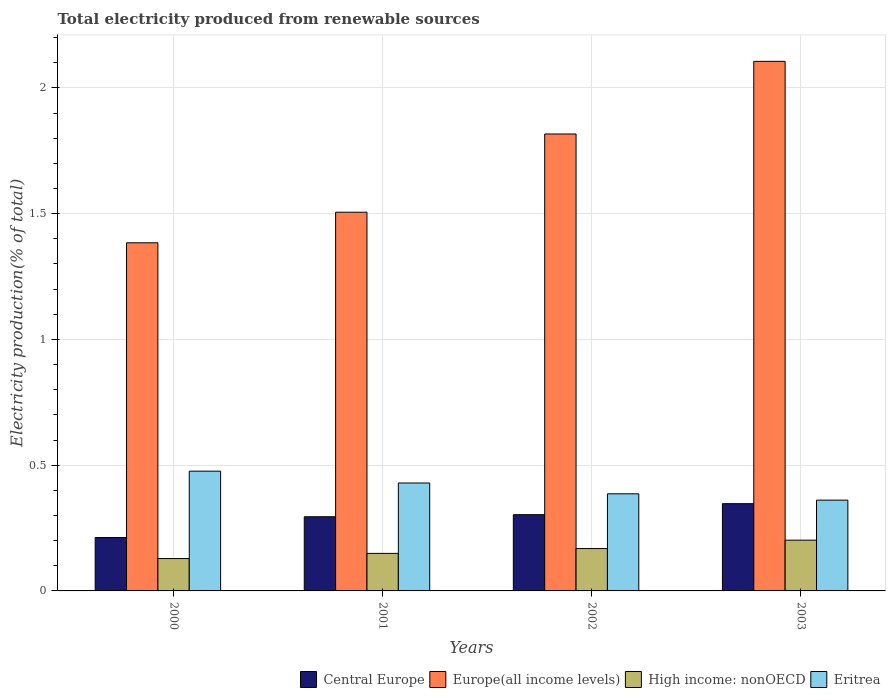How many different coloured bars are there?
Provide a succinct answer. 4. How many groups of bars are there?
Provide a succinct answer. 4. Are the number of bars per tick equal to the number of legend labels?
Give a very brief answer. Yes. Are the number of bars on each tick of the X-axis equal?
Ensure brevity in your answer.  Yes. How many bars are there on the 4th tick from the left?
Your answer should be compact. 4. How many bars are there on the 1st tick from the right?
Keep it short and to the point. 4. What is the label of the 2nd group of bars from the left?
Your answer should be compact. 2001. In how many cases, is the number of bars for a given year not equal to the number of legend labels?
Provide a short and direct response. 0. What is the total electricity produced in Europe(all income levels) in 2000?
Your answer should be compact. 1.38. Across all years, what is the maximum total electricity produced in Europe(all income levels)?
Your response must be concise. 2.11. Across all years, what is the minimum total electricity produced in Eritrea?
Offer a terse response. 0.36. In which year was the total electricity produced in Europe(all income levels) maximum?
Give a very brief answer. 2003. What is the total total electricity produced in Central Europe in the graph?
Keep it short and to the point. 1.16. What is the difference between the total electricity produced in Europe(all income levels) in 2001 and that in 2003?
Offer a very short reply. -0.6. What is the difference between the total electricity produced in Central Europe in 2000 and the total electricity produced in High income: nonOECD in 2001?
Provide a short and direct response. 0.06. What is the average total electricity produced in Central Europe per year?
Offer a terse response. 0.29. In the year 2003, what is the difference between the total electricity produced in Central Europe and total electricity produced in High income: nonOECD?
Make the answer very short. 0.15. In how many years, is the total electricity produced in Eritrea greater than 1.2 %?
Offer a terse response. 0. What is the ratio of the total electricity produced in High income: nonOECD in 2001 to that in 2002?
Your answer should be very brief. 0.89. Is the total electricity produced in High income: nonOECD in 2000 less than that in 2001?
Your response must be concise. Yes. Is the difference between the total electricity produced in Central Europe in 2000 and 2002 greater than the difference between the total electricity produced in High income: nonOECD in 2000 and 2002?
Keep it short and to the point. No. What is the difference between the highest and the second highest total electricity produced in Europe(all income levels)?
Offer a terse response. 0.29. What is the difference between the highest and the lowest total electricity produced in Eritrea?
Your response must be concise. 0.12. In how many years, is the total electricity produced in Europe(all income levels) greater than the average total electricity produced in Europe(all income levels) taken over all years?
Provide a short and direct response. 2. What does the 3rd bar from the left in 2001 represents?
Keep it short and to the point. High income: nonOECD. What does the 1st bar from the right in 2002 represents?
Your answer should be very brief. Eritrea. Are all the bars in the graph horizontal?
Your response must be concise. No. How many years are there in the graph?
Offer a terse response. 4. What is the difference between two consecutive major ticks on the Y-axis?
Make the answer very short. 0.5. Does the graph contain grids?
Keep it short and to the point. Yes. Where does the legend appear in the graph?
Your response must be concise. Bottom right. How are the legend labels stacked?
Provide a short and direct response. Horizontal. What is the title of the graph?
Ensure brevity in your answer.  Total electricity produced from renewable sources. Does "Mauritania" appear as one of the legend labels in the graph?
Provide a succinct answer. No. What is the label or title of the X-axis?
Give a very brief answer. Years. What is the label or title of the Y-axis?
Your response must be concise. Electricity production(% of total). What is the Electricity production(% of total) in Central Europe in 2000?
Keep it short and to the point. 0.21. What is the Electricity production(% of total) of Europe(all income levels) in 2000?
Offer a terse response. 1.38. What is the Electricity production(% of total) in High income: nonOECD in 2000?
Offer a terse response. 0.13. What is the Electricity production(% of total) in Eritrea in 2000?
Offer a very short reply. 0.48. What is the Electricity production(% of total) in Central Europe in 2001?
Provide a succinct answer. 0.29. What is the Electricity production(% of total) in Europe(all income levels) in 2001?
Your response must be concise. 1.51. What is the Electricity production(% of total) of High income: nonOECD in 2001?
Give a very brief answer. 0.15. What is the Electricity production(% of total) in Eritrea in 2001?
Keep it short and to the point. 0.43. What is the Electricity production(% of total) in Central Europe in 2002?
Your answer should be compact. 0.3. What is the Electricity production(% of total) of Europe(all income levels) in 2002?
Your answer should be compact. 1.82. What is the Electricity production(% of total) in High income: nonOECD in 2002?
Offer a terse response. 0.17. What is the Electricity production(% of total) of Eritrea in 2002?
Offer a very short reply. 0.39. What is the Electricity production(% of total) in Central Europe in 2003?
Your answer should be compact. 0.35. What is the Electricity production(% of total) of Europe(all income levels) in 2003?
Your answer should be compact. 2.11. What is the Electricity production(% of total) in High income: nonOECD in 2003?
Keep it short and to the point. 0.2. What is the Electricity production(% of total) in Eritrea in 2003?
Your answer should be very brief. 0.36. Across all years, what is the maximum Electricity production(% of total) in Central Europe?
Your answer should be compact. 0.35. Across all years, what is the maximum Electricity production(% of total) in Europe(all income levels)?
Give a very brief answer. 2.11. Across all years, what is the maximum Electricity production(% of total) in High income: nonOECD?
Offer a terse response. 0.2. Across all years, what is the maximum Electricity production(% of total) of Eritrea?
Provide a short and direct response. 0.48. Across all years, what is the minimum Electricity production(% of total) of Central Europe?
Your response must be concise. 0.21. Across all years, what is the minimum Electricity production(% of total) in Europe(all income levels)?
Ensure brevity in your answer.  1.38. Across all years, what is the minimum Electricity production(% of total) of High income: nonOECD?
Provide a succinct answer. 0.13. Across all years, what is the minimum Electricity production(% of total) in Eritrea?
Make the answer very short. 0.36. What is the total Electricity production(% of total) in Central Europe in the graph?
Provide a short and direct response. 1.16. What is the total Electricity production(% of total) in Europe(all income levels) in the graph?
Keep it short and to the point. 6.81. What is the total Electricity production(% of total) of High income: nonOECD in the graph?
Your response must be concise. 0.65. What is the total Electricity production(% of total) of Eritrea in the graph?
Your answer should be very brief. 1.65. What is the difference between the Electricity production(% of total) of Central Europe in 2000 and that in 2001?
Provide a succinct answer. -0.08. What is the difference between the Electricity production(% of total) in Europe(all income levels) in 2000 and that in 2001?
Offer a terse response. -0.12. What is the difference between the Electricity production(% of total) of High income: nonOECD in 2000 and that in 2001?
Make the answer very short. -0.02. What is the difference between the Electricity production(% of total) of Eritrea in 2000 and that in 2001?
Make the answer very short. 0.05. What is the difference between the Electricity production(% of total) in Central Europe in 2000 and that in 2002?
Give a very brief answer. -0.09. What is the difference between the Electricity production(% of total) in Europe(all income levels) in 2000 and that in 2002?
Provide a short and direct response. -0.43. What is the difference between the Electricity production(% of total) in High income: nonOECD in 2000 and that in 2002?
Make the answer very short. -0.04. What is the difference between the Electricity production(% of total) in Eritrea in 2000 and that in 2002?
Your response must be concise. 0.09. What is the difference between the Electricity production(% of total) of Central Europe in 2000 and that in 2003?
Offer a very short reply. -0.13. What is the difference between the Electricity production(% of total) in Europe(all income levels) in 2000 and that in 2003?
Your response must be concise. -0.72. What is the difference between the Electricity production(% of total) of High income: nonOECD in 2000 and that in 2003?
Give a very brief answer. -0.07. What is the difference between the Electricity production(% of total) in Eritrea in 2000 and that in 2003?
Offer a terse response. 0.12. What is the difference between the Electricity production(% of total) in Central Europe in 2001 and that in 2002?
Offer a very short reply. -0.01. What is the difference between the Electricity production(% of total) of Europe(all income levels) in 2001 and that in 2002?
Your answer should be compact. -0.31. What is the difference between the Electricity production(% of total) in High income: nonOECD in 2001 and that in 2002?
Ensure brevity in your answer.  -0.02. What is the difference between the Electricity production(% of total) of Eritrea in 2001 and that in 2002?
Keep it short and to the point. 0.04. What is the difference between the Electricity production(% of total) in Central Europe in 2001 and that in 2003?
Make the answer very short. -0.05. What is the difference between the Electricity production(% of total) of Europe(all income levels) in 2001 and that in 2003?
Your answer should be very brief. -0.6. What is the difference between the Electricity production(% of total) in High income: nonOECD in 2001 and that in 2003?
Make the answer very short. -0.05. What is the difference between the Electricity production(% of total) of Eritrea in 2001 and that in 2003?
Your answer should be very brief. 0.07. What is the difference between the Electricity production(% of total) in Central Europe in 2002 and that in 2003?
Provide a succinct answer. -0.04. What is the difference between the Electricity production(% of total) in Europe(all income levels) in 2002 and that in 2003?
Keep it short and to the point. -0.29. What is the difference between the Electricity production(% of total) of High income: nonOECD in 2002 and that in 2003?
Provide a short and direct response. -0.03. What is the difference between the Electricity production(% of total) in Eritrea in 2002 and that in 2003?
Provide a short and direct response. 0.03. What is the difference between the Electricity production(% of total) in Central Europe in 2000 and the Electricity production(% of total) in Europe(all income levels) in 2001?
Offer a terse response. -1.29. What is the difference between the Electricity production(% of total) in Central Europe in 2000 and the Electricity production(% of total) in High income: nonOECD in 2001?
Provide a short and direct response. 0.06. What is the difference between the Electricity production(% of total) of Central Europe in 2000 and the Electricity production(% of total) of Eritrea in 2001?
Give a very brief answer. -0.22. What is the difference between the Electricity production(% of total) of Europe(all income levels) in 2000 and the Electricity production(% of total) of High income: nonOECD in 2001?
Your response must be concise. 1.24. What is the difference between the Electricity production(% of total) in Europe(all income levels) in 2000 and the Electricity production(% of total) in Eritrea in 2001?
Your answer should be very brief. 0.96. What is the difference between the Electricity production(% of total) in High income: nonOECD in 2000 and the Electricity production(% of total) in Eritrea in 2001?
Make the answer very short. -0.3. What is the difference between the Electricity production(% of total) in Central Europe in 2000 and the Electricity production(% of total) in Europe(all income levels) in 2002?
Keep it short and to the point. -1.6. What is the difference between the Electricity production(% of total) of Central Europe in 2000 and the Electricity production(% of total) of High income: nonOECD in 2002?
Your response must be concise. 0.04. What is the difference between the Electricity production(% of total) of Central Europe in 2000 and the Electricity production(% of total) of Eritrea in 2002?
Your answer should be very brief. -0.17. What is the difference between the Electricity production(% of total) in Europe(all income levels) in 2000 and the Electricity production(% of total) in High income: nonOECD in 2002?
Ensure brevity in your answer.  1.22. What is the difference between the Electricity production(% of total) in High income: nonOECD in 2000 and the Electricity production(% of total) in Eritrea in 2002?
Your answer should be compact. -0.26. What is the difference between the Electricity production(% of total) in Central Europe in 2000 and the Electricity production(% of total) in Europe(all income levels) in 2003?
Provide a short and direct response. -1.89. What is the difference between the Electricity production(% of total) in Central Europe in 2000 and the Electricity production(% of total) in High income: nonOECD in 2003?
Ensure brevity in your answer.  0.01. What is the difference between the Electricity production(% of total) of Central Europe in 2000 and the Electricity production(% of total) of Eritrea in 2003?
Provide a short and direct response. -0.15. What is the difference between the Electricity production(% of total) in Europe(all income levels) in 2000 and the Electricity production(% of total) in High income: nonOECD in 2003?
Your response must be concise. 1.18. What is the difference between the Electricity production(% of total) of Europe(all income levels) in 2000 and the Electricity production(% of total) of Eritrea in 2003?
Your response must be concise. 1.02. What is the difference between the Electricity production(% of total) of High income: nonOECD in 2000 and the Electricity production(% of total) of Eritrea in 2003?
Ensure brevity in your answer.  -0.23. What is the difference between the Electricity production(% of total) of Central Europe in 2001 and the Electricity production(% of total) of Europe(all income levels) in 2002?
Provide a succinct answer. -1.52. What is the difference between the Electricity production(% of total) in Central Europe in 2001 and the Electricity production(% of total) in High income: nonOECD in 2002?
Keep it short and to the point. 0.13. What is the difference between the Electricity production(% of total) in Central Europe in 2001 and the Electricity production(% of total) in Eritrea in 2002?
Your answer should be very brief. -0.09. What is the difference between the Electricity production(% of total) in Europe(all income levels) in 2001 and the Electricity production(% of total) in High income: nonOECD in 2002?
Keep it short and to the point. 1.34. What is the difference between the Electricity production(% of total) in Europe(all income levels) in 2001 and the Electricity production(% of total) in Eritrea in 2002?
Give a very brief answer. 1.12. What is the difference between the Electricity production(% of total) of High income: nonOECD in 2001 and the Electricity production(% of total) of Eritrea in 2002?
Make the answer very short. -0.24. What is the difference between the Electricity production(% of total) in Central Europe in 2001 and the Electricity production(% of total) in Europe(all income levels) in 2003?
Provide a succinct answer. -1.81. What is the difference between the Electricity production(% of total) of Central Europe in 2001 and the Electricity production(% of total) of High income: nonOECD in 2003?
Ensure brevity in your answer.  0.09. What is the difference between the Electricity production(% of total) in Central Europe in 2001 and the Electricity production(% of total) in Eritrea in 2003?
Give a very brief answer. -0.07. What is the difference between the Electricity production(% of total) in Europe(all income levels) in 2001 and the Electricity production(% of total) in High income: nonOECD in 2003?
Provide a succinct answer. 1.3. What is the difference between the Electricity production(% of total) in Europe(all income levels) in 2001 and the Electricity production(% of total) in Eritrea in 2003?
Keep it short and to the point. 1.14. What is the difference between the Electricity production(% of total) in High income: nonOECD in 2001 and the Electricity production(% of total) in Eritrea in 2003?
Your answer should be compact. -0.21. What is the difference between the Electricity production(% of total) of Central Europe in 2002 and the Electricity production(% of total) of Europe(all income levels) in 2003?
Keep it short and to the point. -1.8. What is the difference between the Electricity production(% of total) of Central Europe in 2002 and the Electricity production(% of total) of High income: nonOECD in 2003?
Your answer should be very brief. 0.1. What is the difference between the Electricity production(% of total) of Central Europe in 2002 and the Electricity production(% of total) of Eritrea in 2003?
Give a very brief answer. -0.06. What is the difference between the Electricity production(% of total) of Europe(all income levels) in 2002 and the Electricity production(% of total) of High income: nonOECD in 2003?
Provide a succinct answer. 1.62. What is the difference between the Electricity production(% of total) of Europe(all income levels) in 2002 and the Electricity production(% of total) of Eritrea in 2003?
Keep it short and to the point. 1.46. What is the difference between the Electricity production(% of total) of High income: nonOECD in 2002 and the Electricity production(% of total) of Eritrea in 2003?
Your response must be concise. -0.19. What is the average Electricity production(% of total) of Central Europe per year?
Your answer should be compact. 0.29. What is the average Electricity production(% of total) of Europe(all income levels) per year?
Your answer should be compact. 1.7. What is the average Electricity production(% of total) in High income: nonOECD per year?
Offer a terse response. 0.16. What is the average Electricity production(% of total) of Eritrea per year?
Your response must be concise. 0.41. In the year 2000, what is the difference between the Electricity production(% of total) in Central Europe and Electricity production(% of total) in Europe(all income levels)?
Offer a terse response. -1.17. In the year 2000, what is the difference between the Electricity production(% of total) in Central Europe and Electricity production(% of total) in High income: nonOECD?
Your response must be concise. 0.08. In the year 2000, what is the difference between the Electricity production(% of total) of Central Europe and Electricity production(% of total) of Eritrea?
Provide a succinct answer. -0.26. In the year 2000, what is the difference between the Electricity production(% of total) of Europe(all income levels) and Electricity production(% of total) of High income: nonOECD?
Ensure brevity in your answer.  1.26. In the year 2000, what is the difference between the Electricity production(% of total) of Europe(all income levels) and Electricity production(% of total) of Eritrea?
Provide a succinct answer. 0.91. In the year 2000, what is the difference between the Electricity production(% of total) in High income: nonOECD and Electricity production(% of total) in Eritrea?
Provide a short and direct response. -0.35. In the year 2001, what is the difference between the Electricity production(% of total) of Central Europe and Electricity production(% of total) of Europe(all income levels)?
Give a very brief answer. -1.21. In the year 2001, what is the difference between the Electricity production(% of total) in Central Europe and Electricity production(% of total) in High income: nonOECD?
Ensure brevity in your answer.  0.15. In the year 2001, what is the difference between the Electricity production(% of total) of Central Europe and Electricity production(% of total) of Eritrea?
Your answer should be very brief. -0.13. In the year 2001, what is the difference between the Electricity production(% of total) of Europe(all income levels) and Electricity production(% of total) of High income: nonOECD?
Provide a short and direct response. 1.36. In the year 2001, what is the difference between the Electricity production(% of total) in Europe(all income levels) and Electricity production(% of total) in Eritrea?
Offer a very short reply. 1.08. In the year 2001, what is the difference between the Electricity production(% of total) in High income: nonOECD and Electricity production(% of total) in Eritrea?
Ensure brevity in your answer.  -0.28. In the year 2002, what is the difference between the Electricity production(% of total) of Central Europe and Electricity production(% of total) of Europe(all income levels)?
Your answer should be compact. -1.51. In the year 2002, what is the difference between the Electricity production(% of total) in Central Europe and Electricity production(% of total) in High income: nonOECD?
Ensure brevity in your answer.  0.13. In the year 2002, what is the difference between the Electricity production(% of total) of Central Europe and Electricity production(% of total) of Eritrea?
Ensure brevity in your answer.  -0.08. In the year 2002, what is the difference between the Electricity production(% of total) of Europe(all income levels) and Electricity production(% of total) of High income: nonOECD?
Give a very brief answer. 1.65. In the year 2002, what is the difference between the Electricity production(% of total) of Europe(all income levels) and Electricity production(% of total) of Eritrea?
Give a very brief answer. 1.43. In the year 2002, what is the difference between the Electricity production(% of total) in High income: nonOECD and Electricity production(% of total) in Eritrea?
Provide a succinct answer. -0.22. In the year 2003, what is the difference between the Electricity production(% of total) of Central Europe and Electricity production(% of total) of Europe(all income levels)?
Keep it short and to the point. -1.76. In the year 2003, what is the difference between the Electricity production(% of total) in Central Europe and Electricity production(% of total) in High income: nonOECD?
Offer a very short reply. 0.15. In the year 2003, what is the difference between the Electricity production(% of total) in Central Europe and Electricity production(% of total) in Eritrea?
Ensure brevity in your answer.  -0.01. In the year 2003, what is the difference between the Electricity production(% of total) of Europe(all income levels) and Electricity production(% of total) of High income: nonOECD?
Offer a very short reply. 1.9. In the year 2003, what is the difference between the Electricity production(% of total) of Europe(all income levels) and Electricity production(% of total) of Eritrea?
Make the answer very short. 1.74. In the year 2003, what is the difference between the Electricity production(% of total) of High income: nonOECD and Electricity production(% of total) of Eritrea?
Provide a succinct answer. -0.16. What is the ratio of the Electricity production(% of total) of Central Europe in 2000 to that in 2001?
Your response must be concise. 0.72. What is the ratio of the Electricity production(% of total) in Europe(all income levels) in 2000 to that in 2001?
Provide a succinct answer. 0.92. What is the ratio of the Electricity production(% of total) of High income: nonOECD in 2000 to that in 2001?
Your response must be concise. 0.86. What is the ratio of the Electricity production(% of total) in Eritrea in 2000 to that in 2001?
Provide a short and direct response. 1.11. What is the ratio of the Electricity production(% of total) in Central Europe in 2000 to that in 2002?
Keep it short and to the point. 0.7. What is the ratio of the Electricity production(% of total) in Europe(all income levels) in 2000 to that in 2002?
Make the answer very short. 0.76. What is the ratio of the Electricity production(% of total) in High income: nonOECD in 2000 to that in 2002?
Offer a terse response. 0.76. What is the ratio of the Electricity production(% of total) of Eritrea in 2000 to that in 2002?
Make the answer very short. 1.23. What is the ratio of the Electricity production(% of total) in Central Europe in 2000 to that in 2003?
Offer a terse response. 0.61. What is the ratio of the Electricity production(% of total) of Europe(all income levels) in 2000 to that in 2003?
Provide a short and direct response. 0.66. What is the ratio of the Electricity production(% of total) of High income: nonOECD in 2000 to that in 2003?
Your answer should be compact. 0.64. What is the ratio of the Electricity production(% of total) in Eritrea in 2000 to that in 2003?
Provide a succinct answer. 1.32. What is the ratio of the Electricity production(% of total) of Europe(all income levels) in 2001 to that in 2002?
Your response must be concise. 0.83. What is the ratio of the Electricity production(% of total) in High income: nonOECD in 2001 to that in 2002?
Provide a succinct answer. 0.89. What is the ratio of the Electricity production(% of total) of Eritrea in 2001 to that in 2002?
Offer a terse response. 1.11. What is the ratio of the Electricity production(% of total) of Central Europe in 2001 to that in 2003?
Give a very brief answer. 0.85. What is the ratio of the Electricity production(% of total) of Europe(all income levels) in 2001 to that in 2003?
Ensure brevity in your answer.  0.72. What is the ratio of the Electricity production(% of total) of High income: nonOECD in 2001 to that in 2003?
Provide a short and direct response. 0.74. What is the ratio of the Electricity production(% of total) of Eritrea in 2001 to that in 2003?
Your answer should be very brief. 1.19. What is the ratio of the Electricity production(% of total) of Central Europe in 2002 to that in 2003?
Keep it short and to the point. 0.87. What is the ratio of the Electricity production(% of total) in Europe(all income levels) in 2002 to that in 2003?
Provide a short and direct response. 0.86. What is the ratio of the Electricity production(% of total) in High income: nonOECD in 2002 to that in 2003?
Your response must be concise. 0.83. What is the ratio of the Electricity production(% of total) of Eritrea in 2002 to that in 2003?
Give a very brief answer. 1.07. What is the difference between the highest and the second highest Electricity production(% of total) in Central Europe?
Keep it short and to the point. 0.04. What is the difference between the highest and the second highest Electricity production(% of total) of Europe(all income levels)?
Keep it short and to the point. 0.29. What is the difference between the highest and the second highest Electricity production(% of total) in High income: nonOECD?
Provide a succinct answer. 0.03. What is the difference between the highest and the second highest Electricity production(% of total) of Eritrea?
Provide a short and direct response. 0.05. What is the difference between the highest and the lowest Electricity production(% of total) of Central Europe?
Provide a short and direct response. 0.13. What is the difference between the highest and the lowest Electricity production(% of total) in Europe(all income levels)?
Your response must be concise. 0.72. What is the difference between the highest and the lowest Electricity production(% of total) of High income: nonOECD?
Your response must be concise. 0.07. What is the difference between the highest and the lowest Electricity production(% of total) in Eritrea?
Provide a short and direct response. 0.12. 